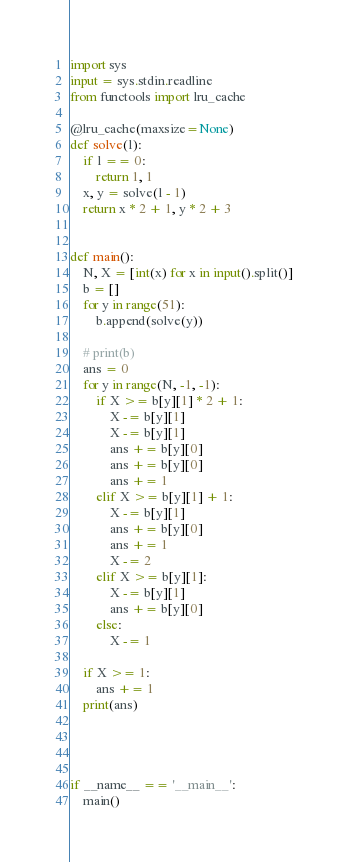<code> <loc_0><loc_0><loc_500><loc_500><_Python_>import sys
input = sys.stdin.readline
from functools import lru_cache

@lru_cache(maxsize=None)
def solve(l):
    if l == 0:
        return 1, 1
    x, y = solve(l - 1)
    return x * 2 + 1, y * 2 + 3


def main():
    N, X = [int(x) for x in input().split()]
    b = []
    for y in range(51):
        b.append(solve(y))

    # print(b)
    ans = 0
    for y in range(N, -1, -1):
        if X >= b[y][1] * 2 + 1:
            X -= b[y][1]
            X -= b[y][1]
            ans += b[y][0]
            ans += b[y][0]
            ans += 1
        elif X >= b[y][1] + 1:
            X -= b[y][1]
            ans += b[y][0]
            ans += 1
            X -= 2
        elif X >= b[y][1]:
            X -= b[y][1]
            ans += b[y][0]
        else:
            X -= 1

    if X >= 1:
        ans += 1
    print(ans)




if __name__ == '__main__':
    main()

</code> 